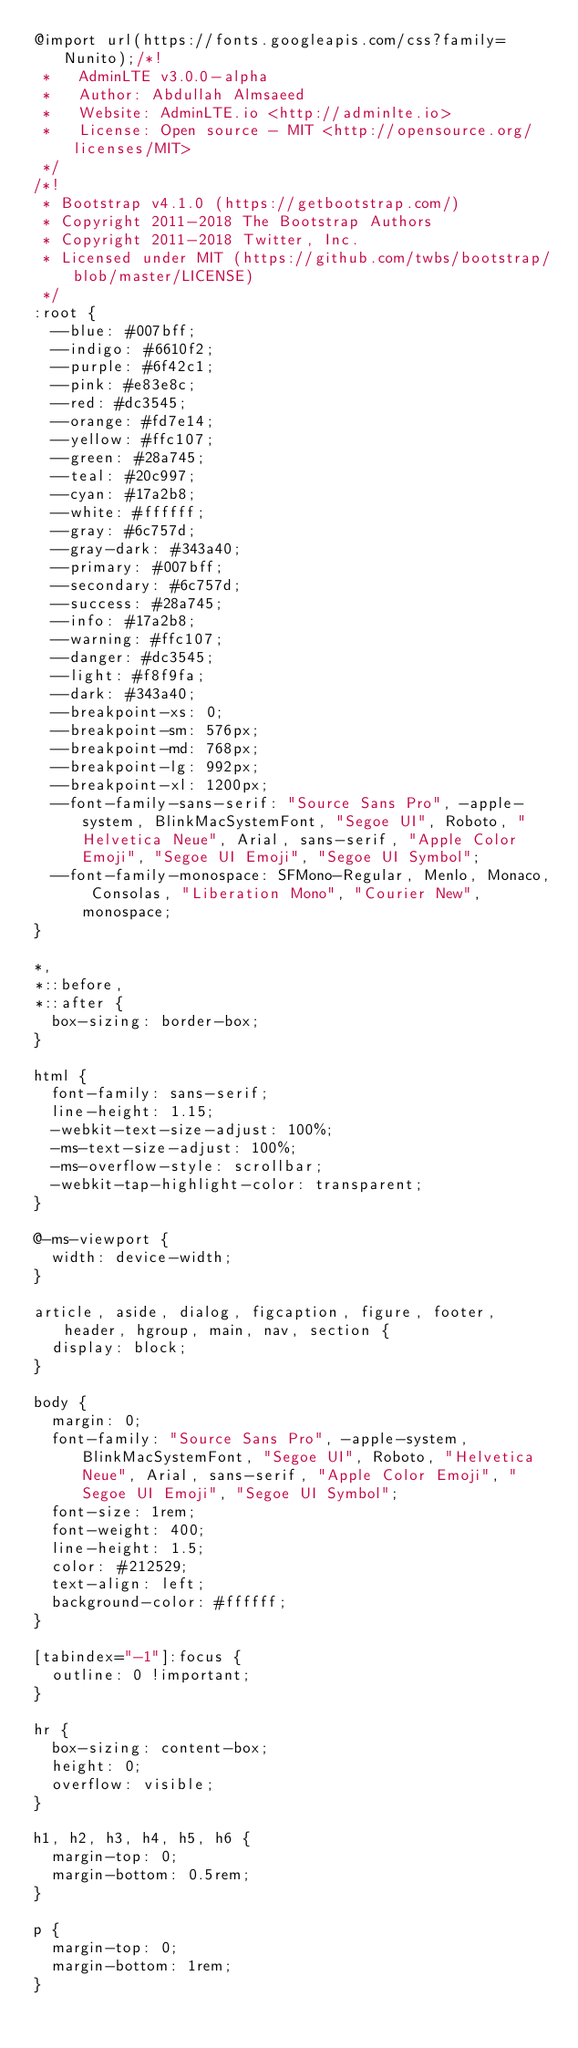Convert code to text. <code><loc_0><loc_0><loc_500><loc_500><_CSS_>@import url(https://fonts.googleapis.com/css?family=Nunito);/*!
 *   AdminLTE v3.0.0-alpha
 *   Author: Abdullah Almsaeed
 *	 Website: AdminLTE.io <http://adminlte.io>
 *   License: Open source - MIT <http://opensource.org/licenses/MIT>
 */
/*!
 * Bootstrap v4.1.0 (https://getbootstrap.com/)
 * Copyright 2011-2018 The Bootstrap Authors
 * Copyright 2011-2018 Twitter, Inc.
 * Licensed under MIT (https://github.com/twbs/bootstrap/blob/master/LICENSE)
 */
:root {
  --blue: #007bff;
  --indigo: #6610f2;
  --purple: #6f42c1;
  --pink: #e83e8c;
  --red: #dc3545;
  --orange: #fd7e14;
  --yellow: #ffc107;
  --green: #28a745;
  --teal: #20c997;
  --cyan: #17a2b8;
  --white: #ffffff;
  --gray: #6c757d;
  --gray-dark: #343a40;
  --primary: #007bff;
  --secondary: #6c757d;
  --success: #28a745;
  --info: #17a2b8;
  --warning: #ffc107;
  --danger: #dc3545;
  --light: #f8f9fa;
  --dark: #343a40;
  --breakpoint-xs: 0;
  --breakpoint-sm: 576px;
  --breakpoint-md: 768px;
  --breakpoint-lg: 992px;
  --breakpoint-xl: 1200px;
  --font-family-sans-serif: "Source Sans Pro", -apple-system, BlinkMacSystemFont, "Segoe UI", Roboto, "Helvetica Neue", Arial, sans-serif, "Apple Color Emoji", "Segoe UI Emoji", "Segoe UI Symbol";
  --font-family-monospace: SFMono-Regular, Menlo, Monaco, Consolas, "Liberation Mono", "Courier New", monospace;
}

*,
*::before,
*::after {
  box-sizing: border-box;
}

html {
  font-family: sans-serif;
  line-height: 1.15;
  -webkit-text-size-adjust: 100%;
  -ms-text-size-adjust: 100%;
  -ms-overflow-style: scrollbar;
  -webkit-tap-highlight-color: transparent;
}

@-ms-viewport {
  width: device-width;
}

article, aside, dialog, figcaption, figure, footer, header, hgroup, main, nav, section {
  display: block;
}

body {
  margin: 0;
  font-family: "Source Sans Pro", -apple-system, BlinkMacSystemFont, "Segoe UI", Roboto, "Helvetica Neue", Arial, sans-serif, "Apple Color Emoji", "Segoe UI Emoji", "Segoe UI Symbol";
  font-size: 1rem;
  font-weight: 400;
  line-height: 1.5;
  color: #212529;
  text-align: left;
  background-color: #ffffff;
}

[tabindex="-1"]:focus {
  outline: 0 !important;
}

hr {
  box-sizing: content-box;
  height: 0;
  overflow: visible;
}

h1, h2, h3, h4, h5, h6 {
  margin-top: 0;
  margin-bottom: 0.5rem;
}

p {
  margin-top: 0;
  margin-bottom: 1rem;
}
</code> 